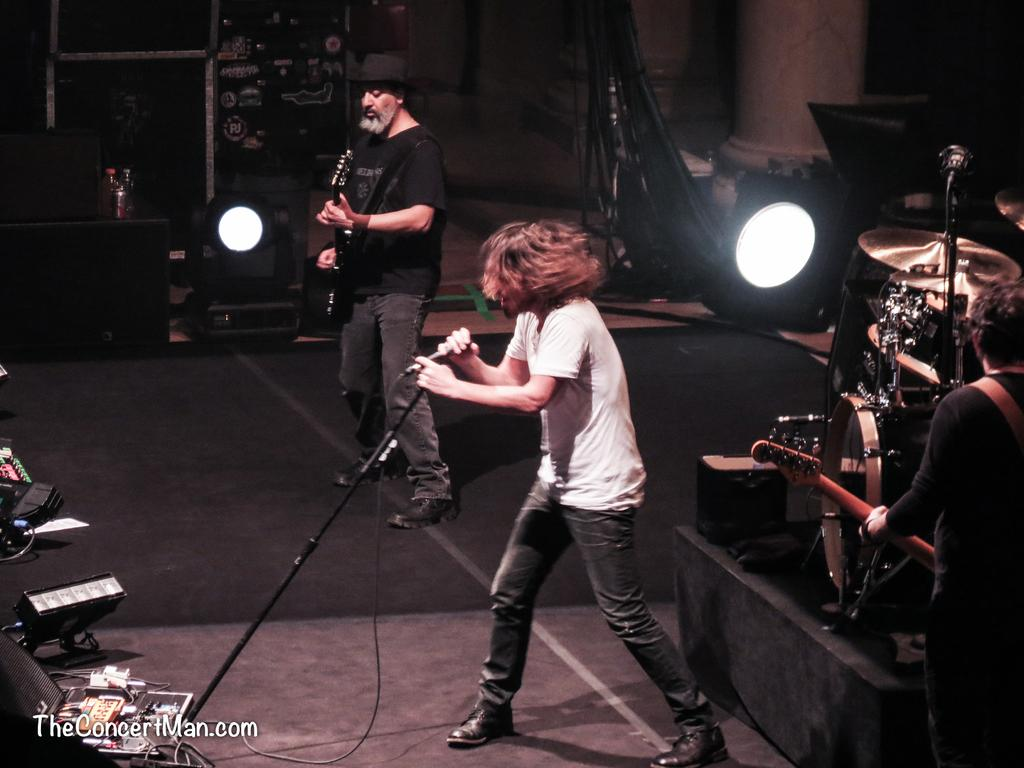How many people are in the image? There are two persons in the image. What are the persons doing in the image? One person is singing into a microphone and playing a guitar, while the other person is standing nearby. What is the surface on which the persons are standing? The persons are standing on the floor. What can be seen in the image that might be related to lighting? There are lights visible in the image. What other objects are present in the image that might be related to music? There are musical instruments in the image. What type of ring is the person wearing on their finger while playing the guitar? There is no ring visible on the person's finger in the image. What emotion might the person feel if they were experiencing shame while singing into the microphone? There is no indication of shame or any emotions in the image, as the person appears to be focused on singing and playing the guitar. 